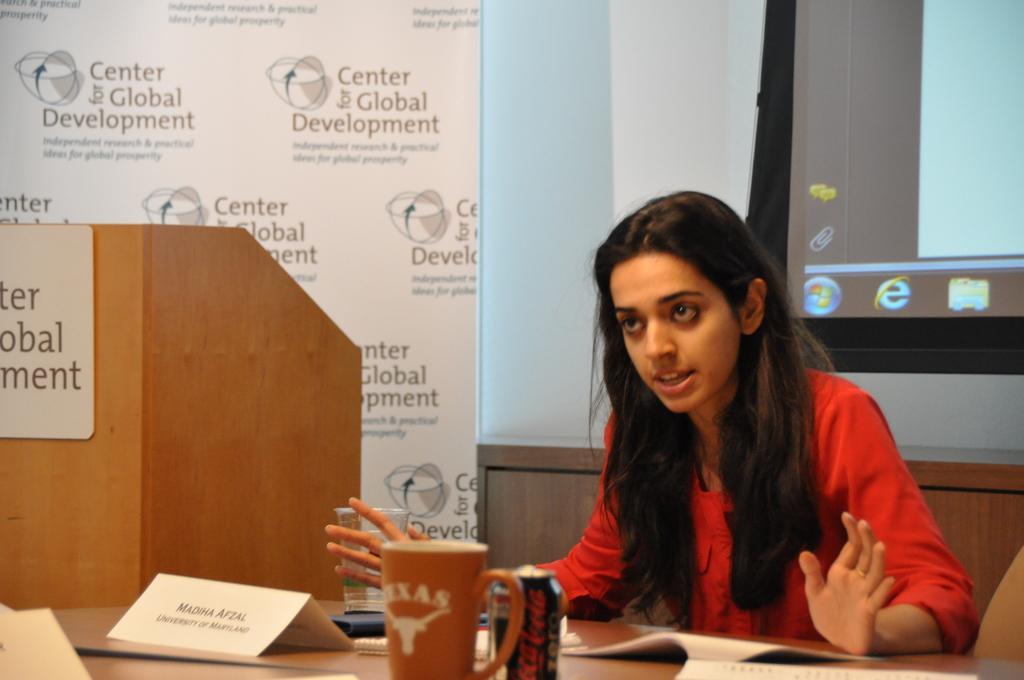Can you describe this image briefly? In this picture there is a woman sitting, in front of her we can see tin, cup, board, papers and glass on the table and we can see board on the podium. In the background of the image we can see screen, hoarding and wall. 